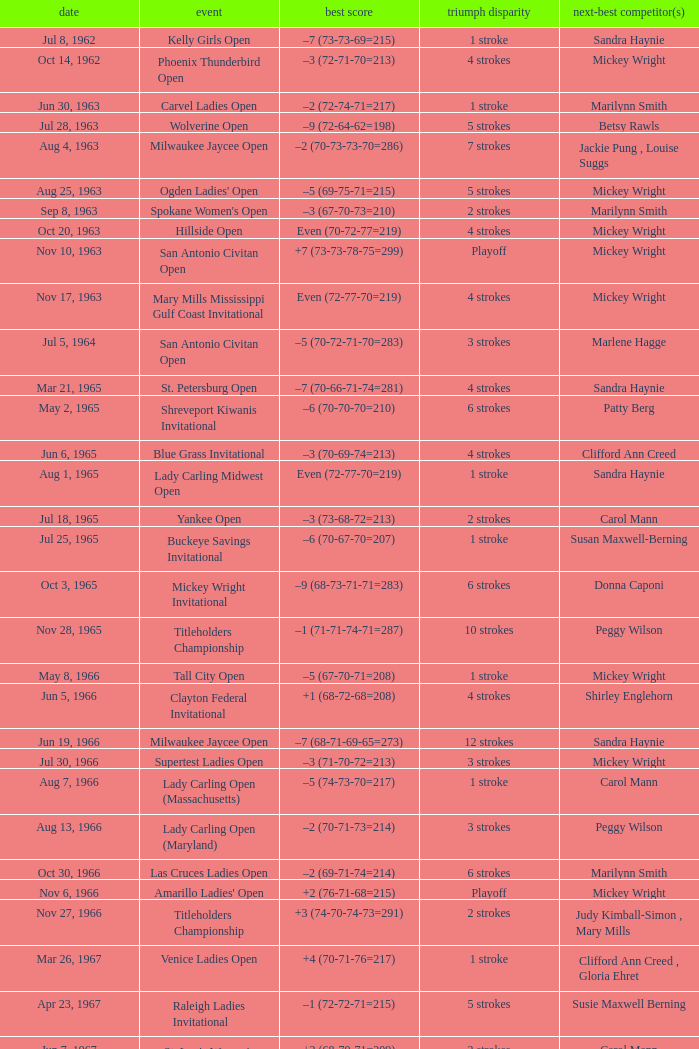What was the margin of victory on Apr 23, 1967? 5 strokes. 